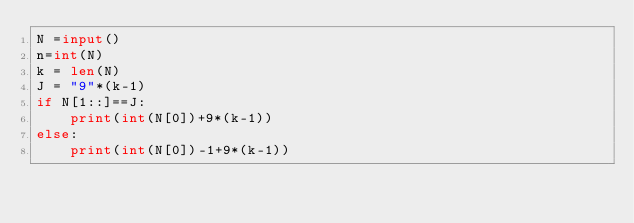<code> <loc_0><loc_0><loc_500><loc_500><_Python_>N =input()
n=int(N)
k = len(N)
J = "9"*(k-1)
if N[1::]==J:
    print(int(N[0])+9*(k-1))
else:
    print(int(N[0])-1+9*(k-1))

</code> 